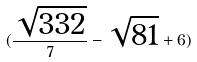Convert formula to latex. <formula><loc_0><loc_0><loc_500><loc_500>( \frac { \sqrt { 3 3 2 } } { 7 } - \sqrt { 8 1 } + 6 )</formula> 